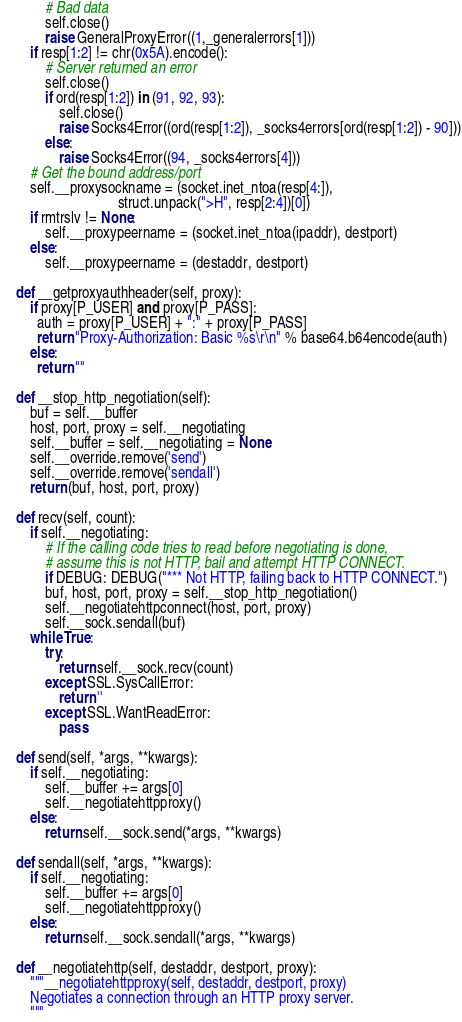Convert code to text. <code><loc_0><loc_0><loc_500><loc_500><_Python_>            # Bad data
            self.close()
            raise GeneralProxyError((1,_generalerrors[1]))
        if resp[1:2] != chr(0x5A).encode():
            # Server returned an error
            self.close()
            if ord(resp[1:2]) in (91, 92, 93):
                self.close()
                raise Socks4Error((ord(resp[1:2]), _socks4errors[ord(resp[1:2]) - 90]))
            else:
                raise Socks4Error((94, _socks4errors[4]))
        # Get the bound address/port
        self.__proxysockname = (socket.inet_ntoa(resp[4:]),
                                struct.unpack(">H", resp[2:4])[0])
        if rmtrslv != None:
            self.__proxypeername = (socket.inet_ntoa(ipaddr), destport)
        else:
            self.__proxypeername = (destaddr, destport)

    def __getproxyauthheader(self, proxy):
        if proxy[P_USER] and proxy[P_PASS]:
          auth = proxy[P_USER] + ":" + proxy[P_PASS]
          return "Proxy-Authorization: Basic %s\r\n" % base64.b64encode(auth)
        else:
          return ""

    def __stop_http_negotiation(self):
        buf = self.__buffer
        host, port, proxy = self.__negotiating
        self.__buffer = self.__negotiating = None
        self.__override.remove('send')
        self.__override.remove('sendall')
        return (buf, host, port, proxy)

    def recv(self, count):
        if self.__negotiating:
            # If the calling code tries to read before negotiating is done,
            # assume this is not HTTP, bail and attempt HTTP CONNECT.
            if DEBUG: DEBUG("*** Not HTTP, failing back to HTTP CONNECT.")
            buf, host, port, proxy = self.__stop_http_negotiation()
            self.__negotiatehttpconnect(host, port, proxy)
            self.__sock.sendall(buf)
        while True:
            try:
                return self.__sock.recv(count)
            except SSL.SysCallError:
                return ''
            except SSL.WantReadError:
                pass

    def send(self, *args, **kwargs):
        if self.__negotiating:
            self.__buffer += args[0]
            self.__negotiatehttpproxy()
        else:
            return self.__sock.send(*args, **kwargs)

    def sendall(self, *args, **kwargs):
        if self.__negotiating:
            self.__buffer += args[0]
            self.__negotiatehttpproxy()
        else:
            return self.__sock.sendall(*args, **kwargs)

    def __negotiatehttp(self, destaddr, destport, proxy):
        """__negotiatehttpproxy(self, destaddr, destport, proxy)
        Negotiates a connection through an HTTP proxy server.
        """</code> 